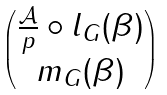Convert formula to latex. <formula><loc_0><loc_0><loc_500><loc_500>\begin{pmatrix} \frac { \mathcal { A } } p \circ l _ { G } ( \beta ) \\ m _ { G } ( \beta ) \end{pmatrix}</formula> 